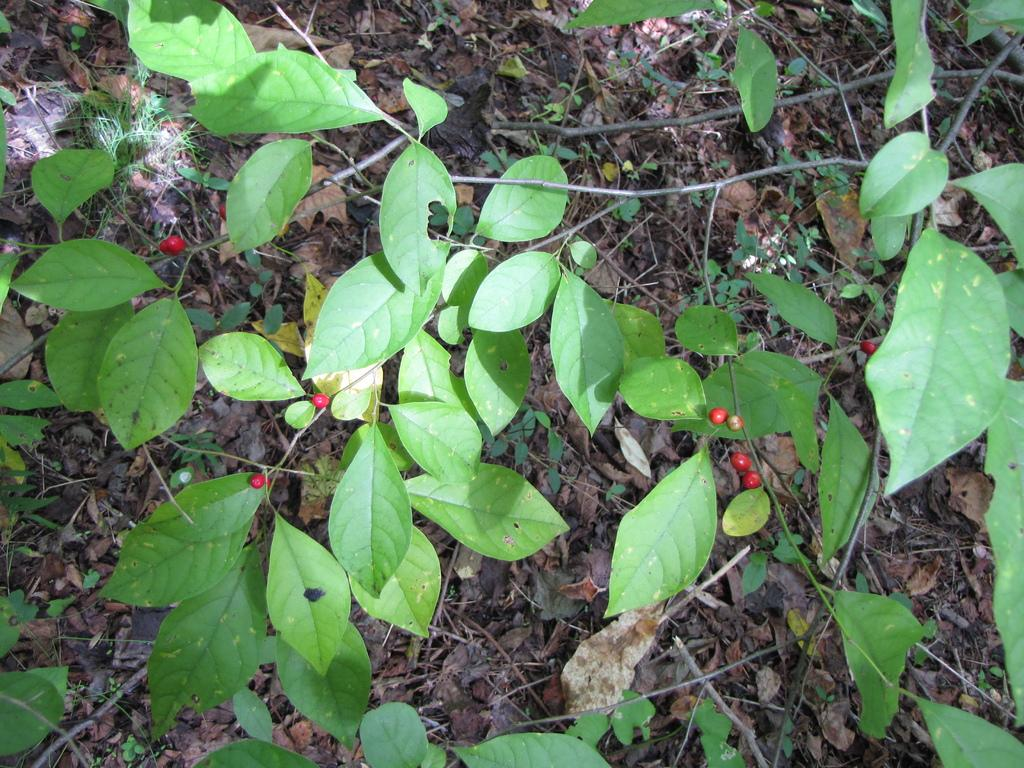What type of food can be seen in the image? There are fruits in the image. What other natural elements are present in the image? There are plants and leaves on the ground visible in the image. What type of vegetation can be seen in the image? There is grass visible in the image. What type of neck accessory is visible in the image? There is no neck accessory present in the image. Can you tell me how many apples are in the image? The provided facts do not specify the type of fruits in the image, so it cannot be determined if there are any apples present. 